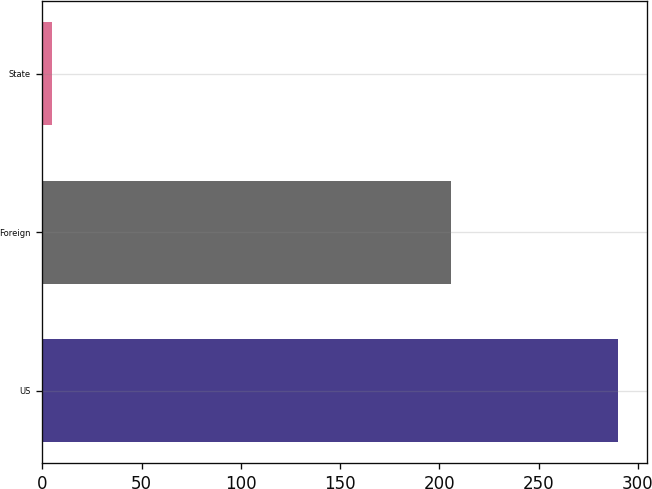Convert chart. <chart><loc_0><loc_0><loc_500><loc_500><bar_chart><fcel>US<fcel>Foreign<fcel>State<nl><fcel>290<fcel>206<fcel>5<nl></chart> 